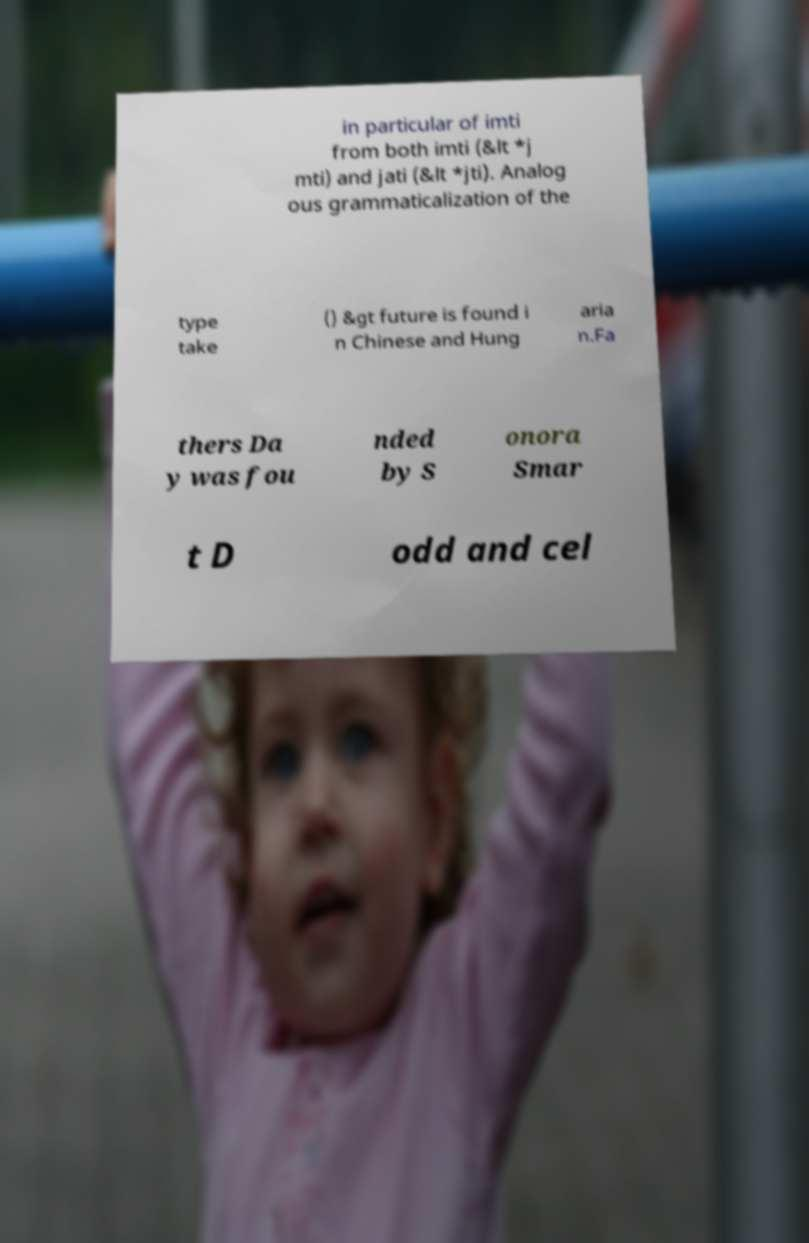Can you accurately transcribe the text from the provided image for me? in particular of imti from both imti (&lt *j mti) and jati (&lt *jti). Analog ous grammaticalization of the type take () &gt future is found i n Chinese and Hung aria n.Fa thers Da y was fou nded by S onora Smar t D odd and cel 